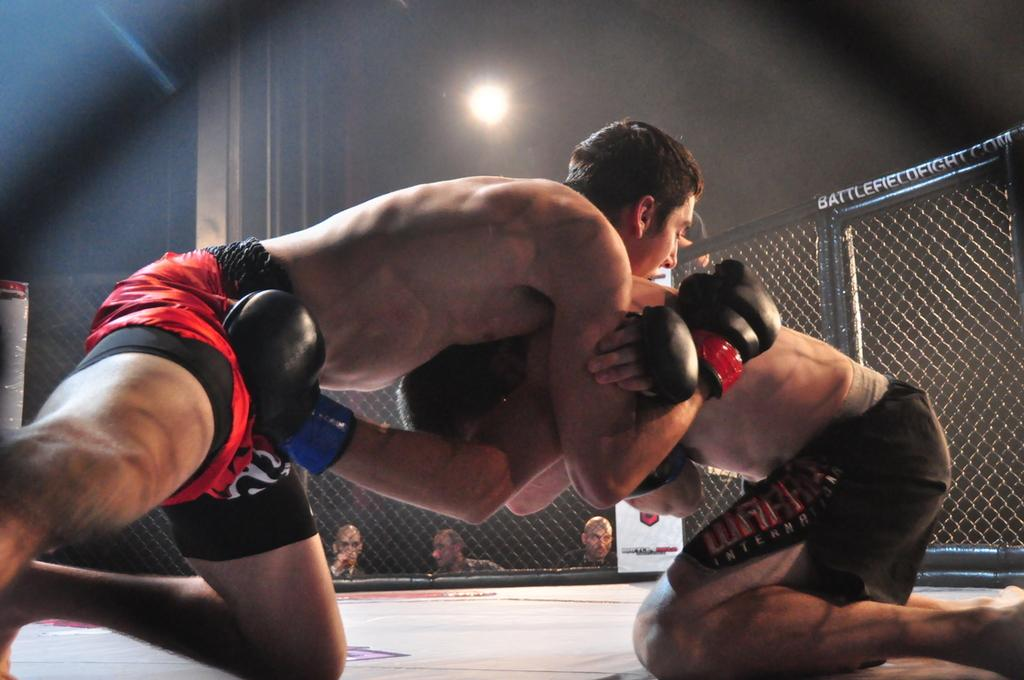What are the two people in the image doing? The two people in the image are wrestling. What can be seen in the background of the image? There is a net and people visible in the background of the image. What object is present in the image besides the wrestling people? There is a board in the image. What is the source of light visible at the top of the image? There is a light visible at the top of the image. What type of tank is visible in the image? There is no tank present in the image. How does the expansion of the wrestling area affect the people in the background? The image does not show any expansion of the wrestling area, so it cannot be determined how it would affect the people in the background. 